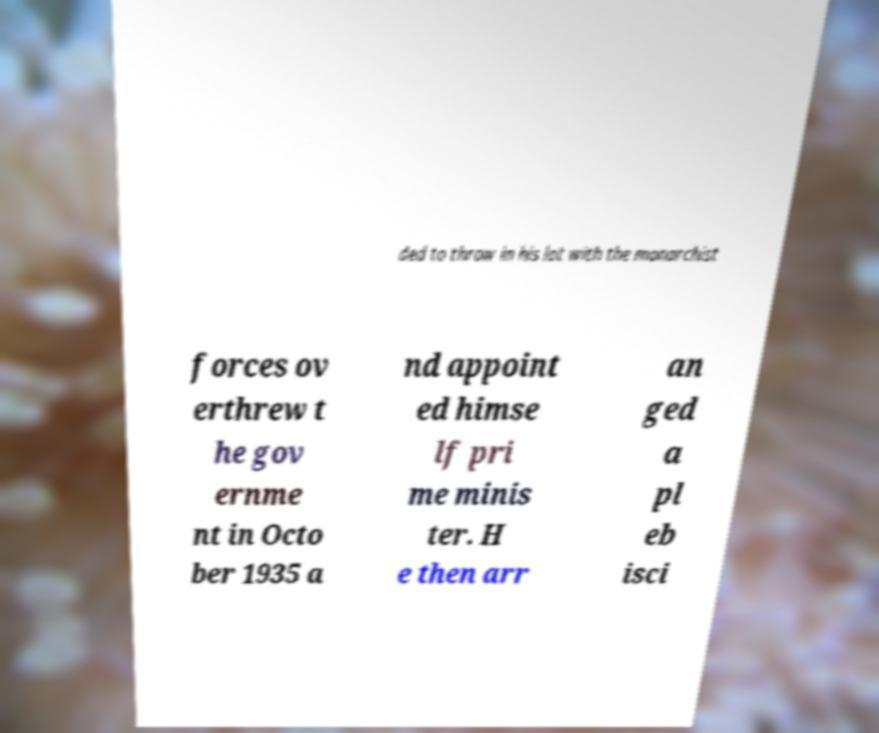What messages or text are displayed in this image? I need them in a readable, typed format. ded to throw in his lot with the monarchist forces ov erthrew t he gov ernme nt in Octo ber 1935 a nd appoint ed himse lf pri me minis ter. H e then arr an ged a pl eb isci 